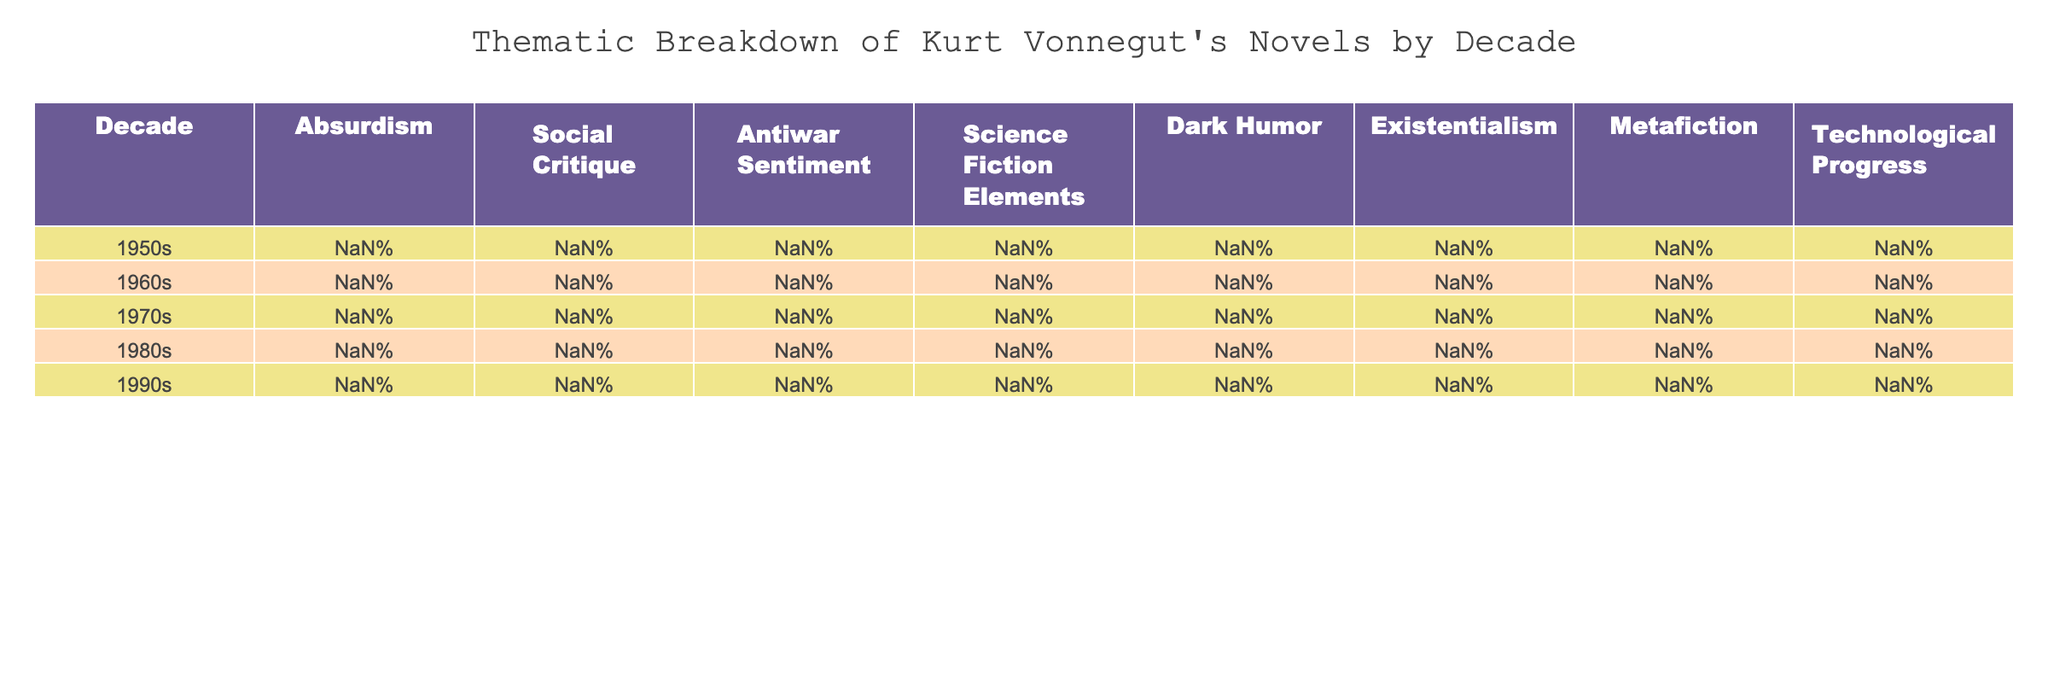What decade saw the highest percentage of Absurdism in Vonnegut's novels? By examining the column for Absurdism, the highest percentage is found in the 1970s at 65%.
Answer: 1970s Which decade had the lowest Antiwar Sentiment in Kurt Vonnegut's novels? The column for Antiwar Sentiment shows that the decade with the lowest percentage is the 1990s at 35%.
Answer: 1990s What is the average percentage of Dark Humor across all decades? To find the average, we add the percentages: (35 + 60 + 70 + 65 + 60) = 290. There are 5 decades, so the average is 290/5 = 58%.
Answer: 58% Which two decades had the same percentage of Social Critique? Looking closely, the 1980s and 1990s both have a Social Critique value of 70% and 75% respectively.
Answer: No, the values differ In which decade did Science Fiction Elements reach its peak, and what was the percentage? Checking the Science Fiction Elements column, its peak occurs in the 1960s with a value of 75%.
Answer: 1960s, 75% What is the difference in Technological Progress between the 1960s and the 1970s? From the Technological Progress column, the 1960s has 65% and the 1970s has 55%. The difference is 65% - 55% = 10%.
Answer: 10% How many thematic elements exceeded 50% in the 1980s? In the 1980s, we see the themes of Social Critique (70%), Dark Humor (65%), and Existentialism (60%) exceed 50%. Therefore, that totals to three themes.
Answer: 3 What is the trend in Existentialism percentages from the 1950s to the 1990s? By analyzing the Existentialism percentages: 25% (1950s), 40% (1960s), 55% (1970s), 60% (1980s), and 65% (1990s), the trend clearly shows an upward increase over the decades.
Answer: Increasing trend Which decade had the highest percentage of Metafiction, and how does it compare to the 1950s? The highest percentage of Metafiction is in the 1970s at 45%. The 1950s had only 10%, making the difference 35%.
Answer: 1970s, 35% higher than 1950s What is the overall percentage of Absurdism across all decades? The total Absurdism percentages are: 40% + 55% + 65% + 50% + 45% = 255%. With 5 decades, the average is 255% / 5 = 51%.
Answer: 51% 